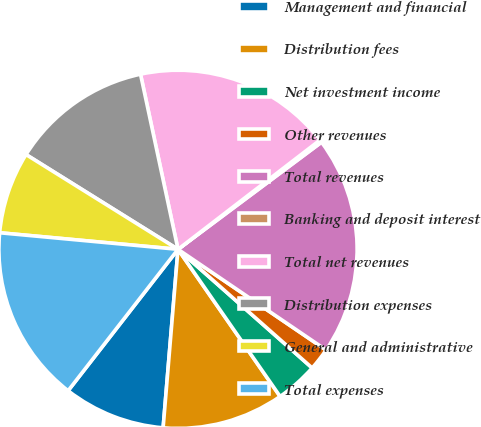<chart> <loc_0><loc_0><loc_500><loc_500><pie_chart><fcel>Management and financial<fcel>Distribution fees<fcel>Net investment income<fcel>Other revenues<fcel>Total revenues<fcel>Banking and deposit interest<fcel>Total net revenues<fcel>Distribution expenses<fcel>General and administrative<fcel>Total expenses<nl><fcel>9.19%<fcel>10.98%<fcel>3.82%<fcel>2.02%<fcel>19.71%<fcel>0.23%<fcel>17.92%<fcel>12.77%<fcel>7.4%<fcel>15.96%<nl></chart> 